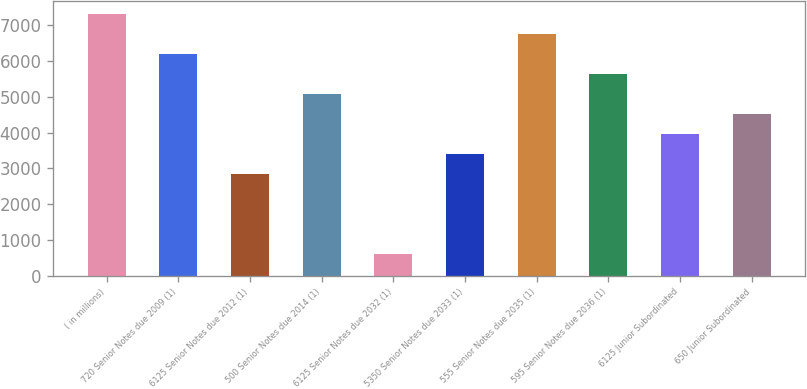<chart> <loc_0><loc_0><loc_500><loc_500><bar_chart><fcel>( in millions)<fcel>720 Senior Notes due 2009 (1)<fcel>6125 Senior Notes due 2012 (1)<fcel>500 Senior Notes due 2014 (1)<fcel>6125 Senior Notes due 2032 (1)<fcel>5350 Senior Notes due 2033 (1)<fcel>555 Senior Notes due 2035 (1)<fcel>595 Senior Notes due 2036 (1)<fcel>6125 Junior Subordinated<fcel>650 Junior Subordinated<nl><fcel>7320<fcel>6200<fcel>2840<fcel>5080<fcel>600<fcel>3400<fcel>6760<fcel>5640<fcel>3960<fcel>4520<nl></chart> 